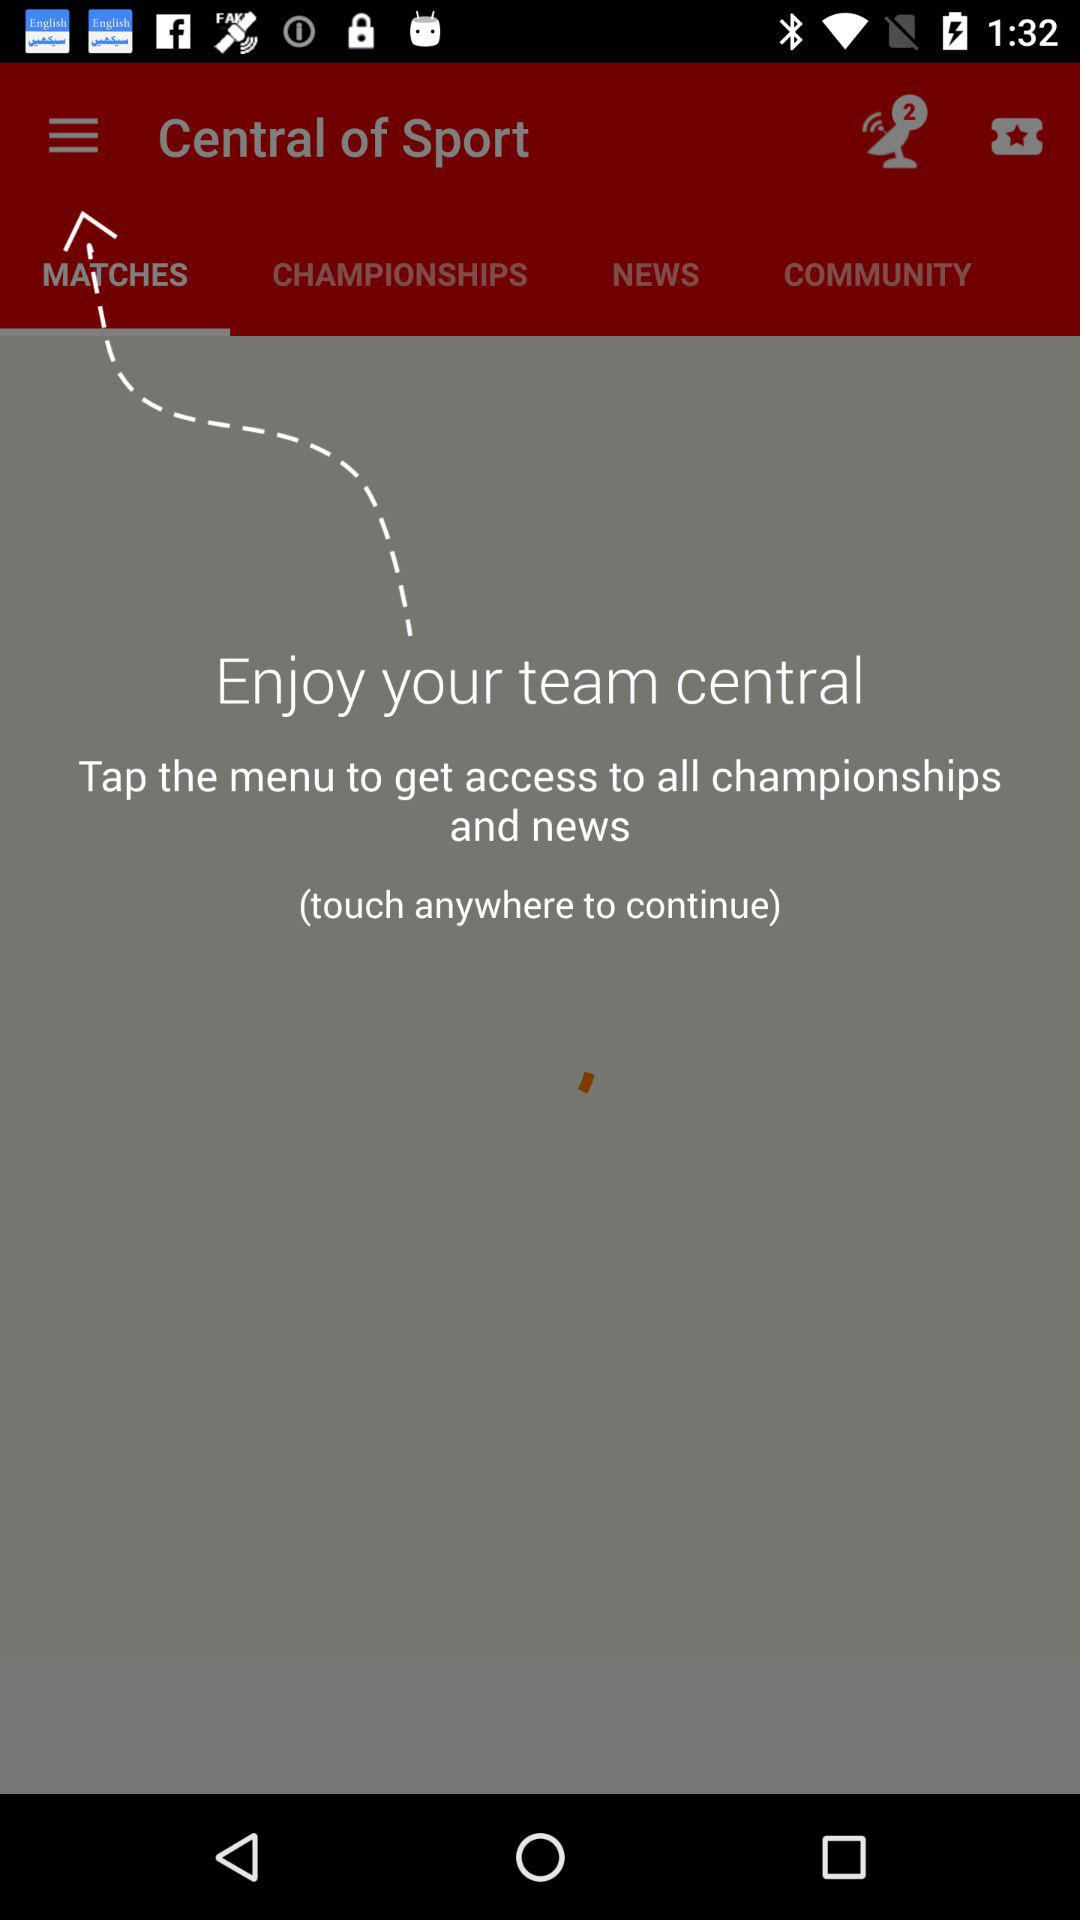Which tab of "Central of Sport" am I on? You are on the "MATCHES" tab. 